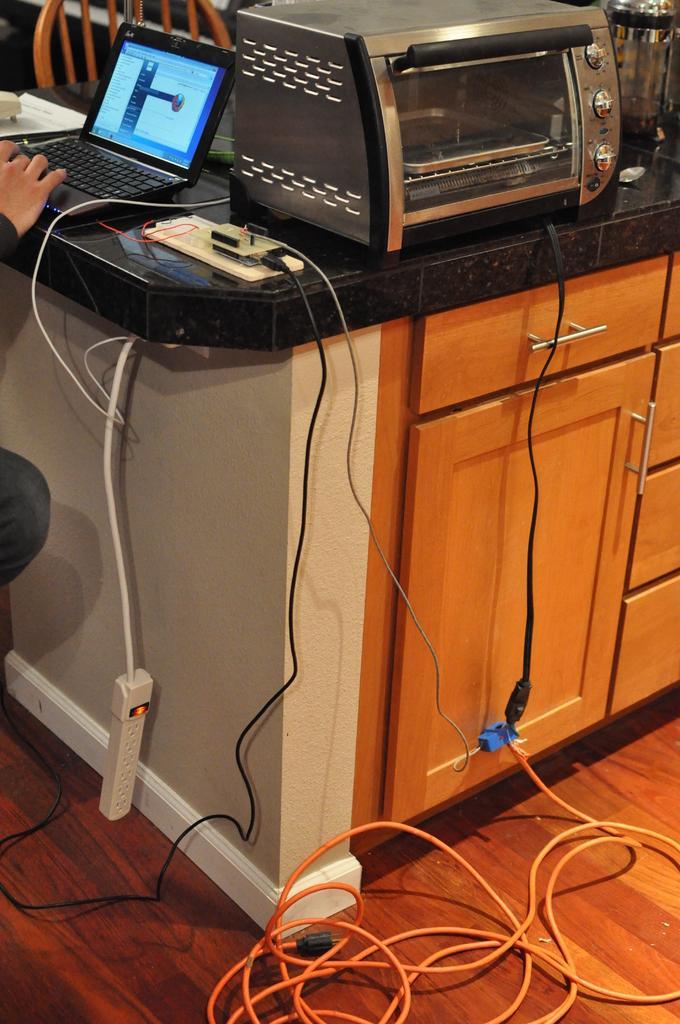Please provide a concise description of this image. In this picture we can see a person on the left side. There is a laptop, white object, switchboards, wires, microwave oven and a kitchen vessel on a wooden desk. We can see a chair in the background. 